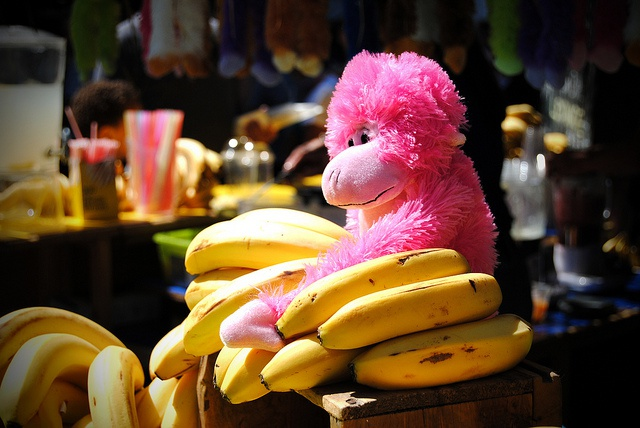Describe the objects in this image and their specific colors. I can see banana in black, olive, orange, and maroon tones, banana in black, maroon, olive, and tan tones, banana in black, orange, olive, ivory, and khaki tones, cup in black, tan, salmon, lightpink, and red tones, and banana in black, orange, ivory, khaki, and gold tones in this image. 